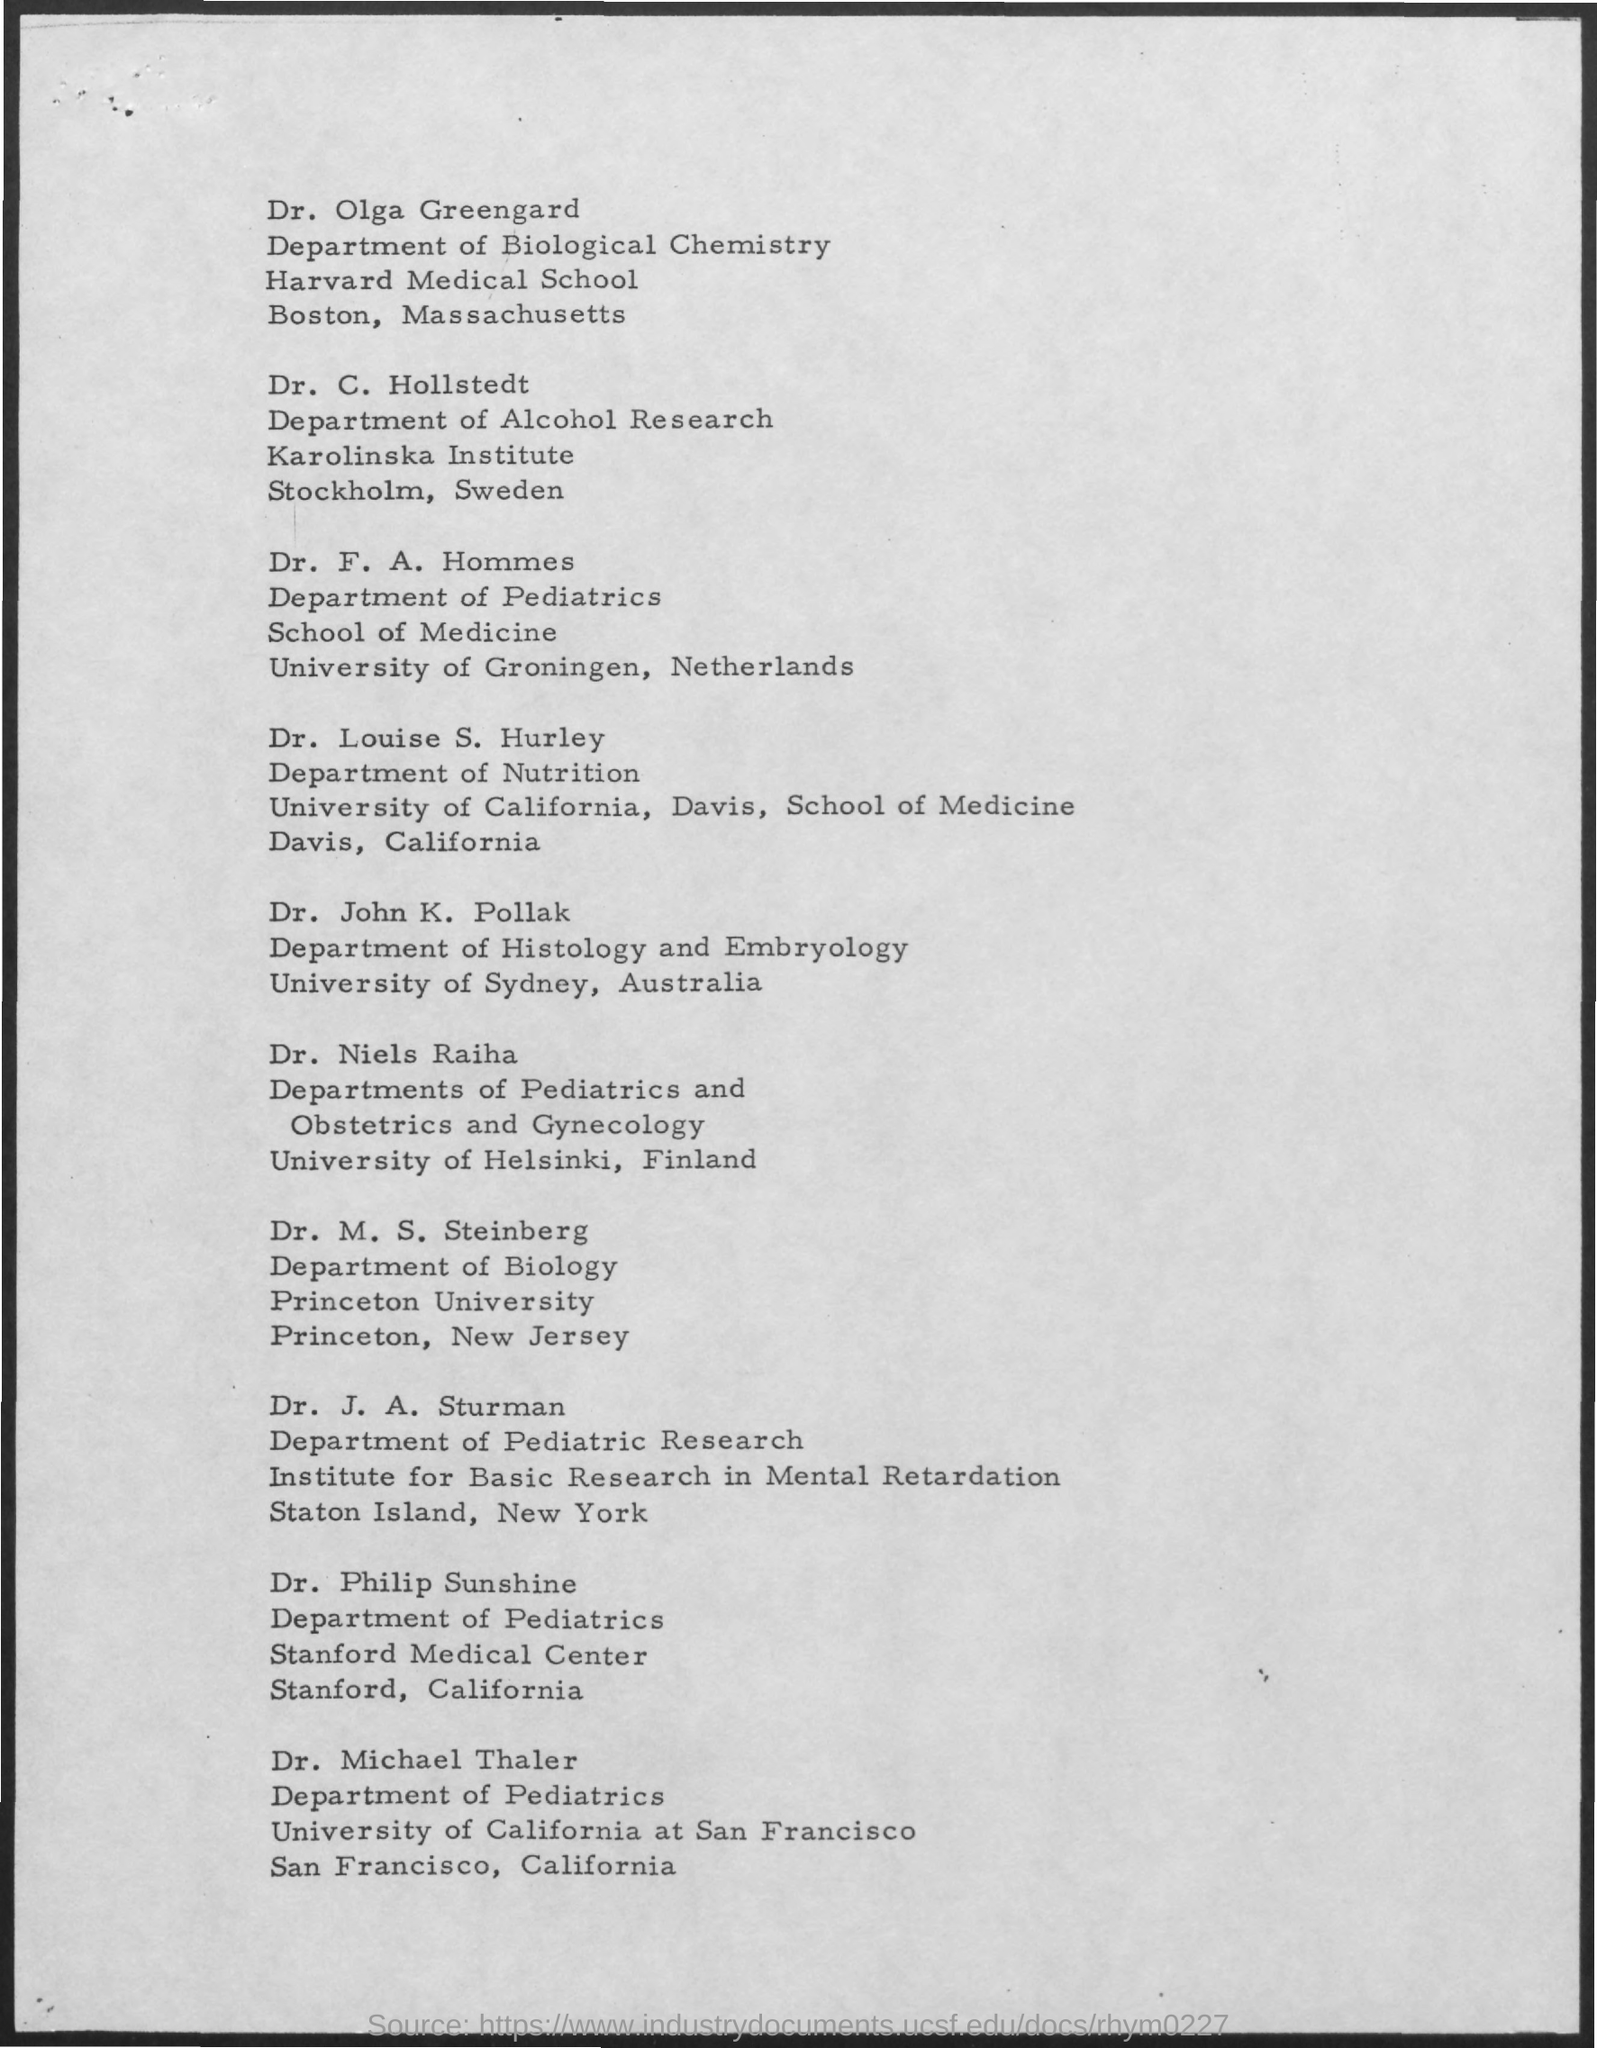University of Helsinki is in which country?
Ensure brevity in your answer.  Finland. Dr.Olga Greengard is in which department?
Ensure brevity in your answer.  Department of biological chemistry. 